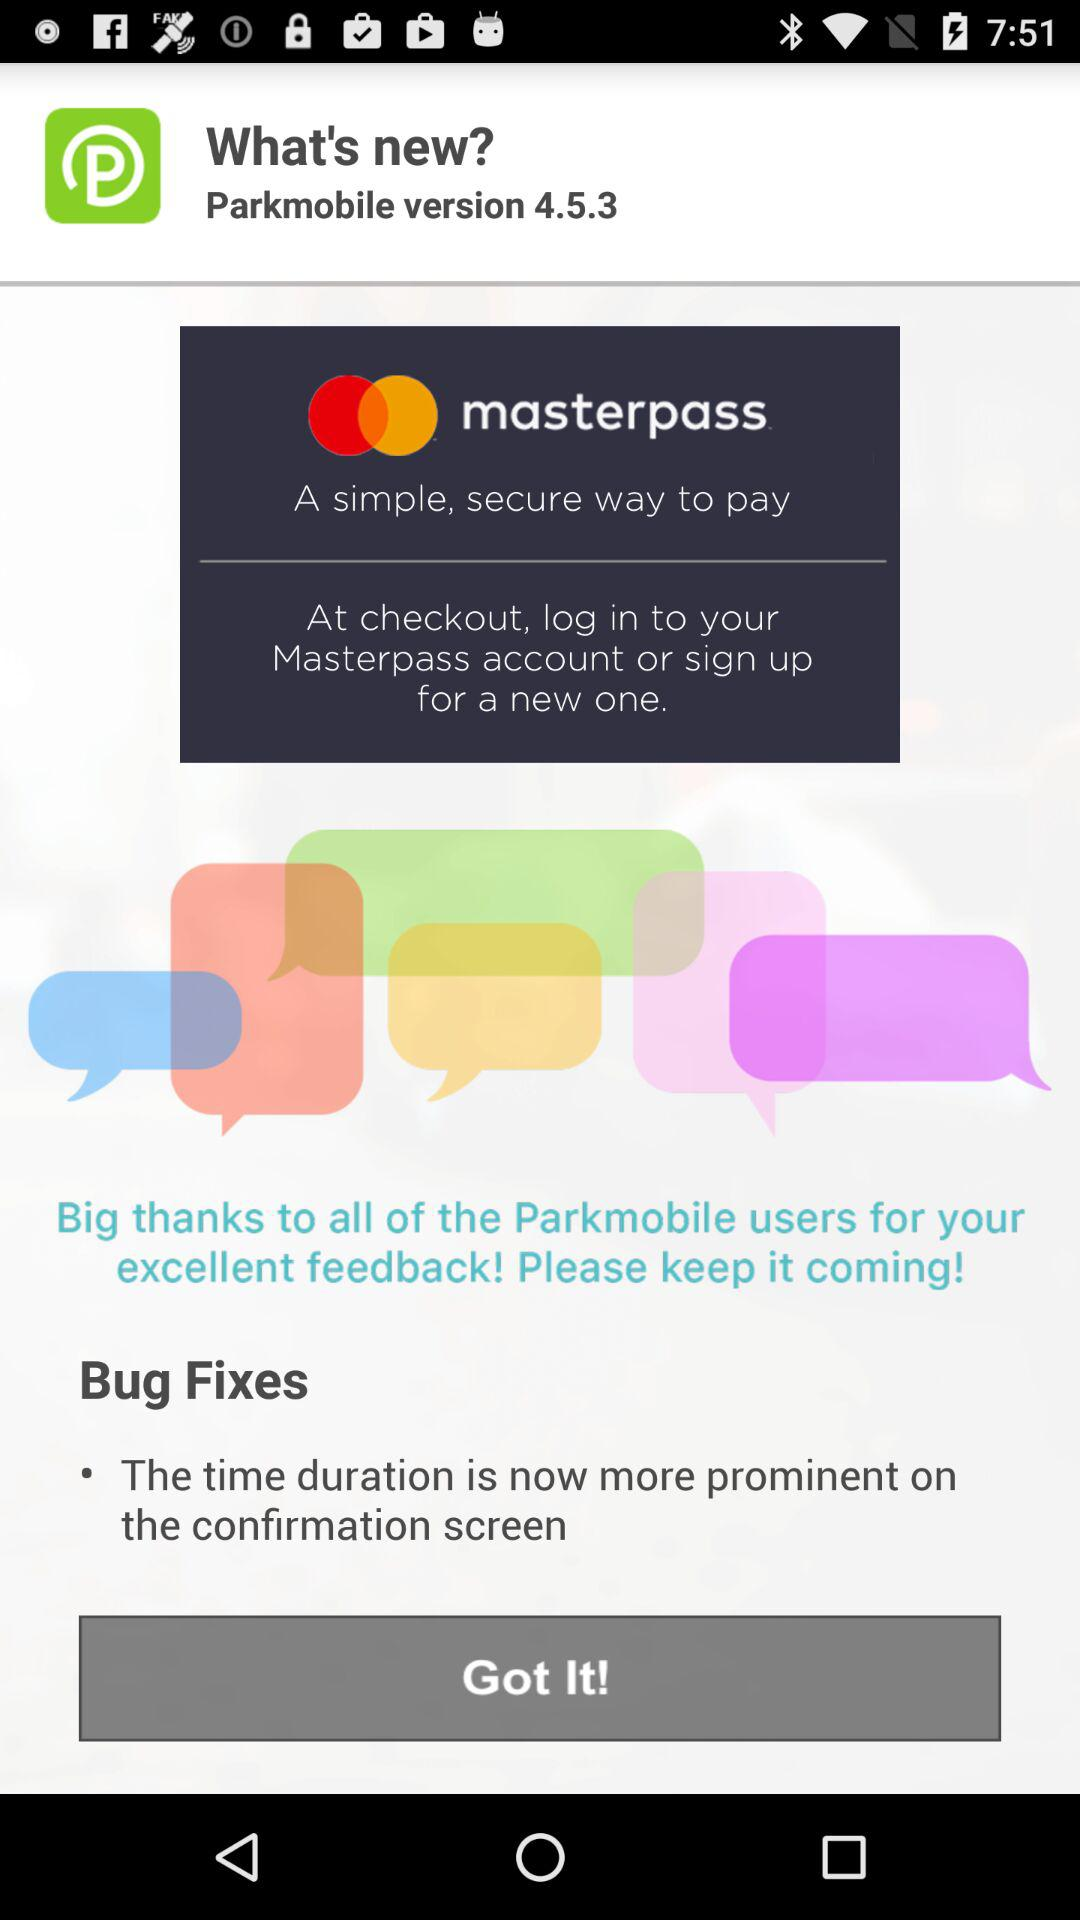Is "Got It!" selected?
When the provided information is insufficient, respond with <no answer>. <no answer> 